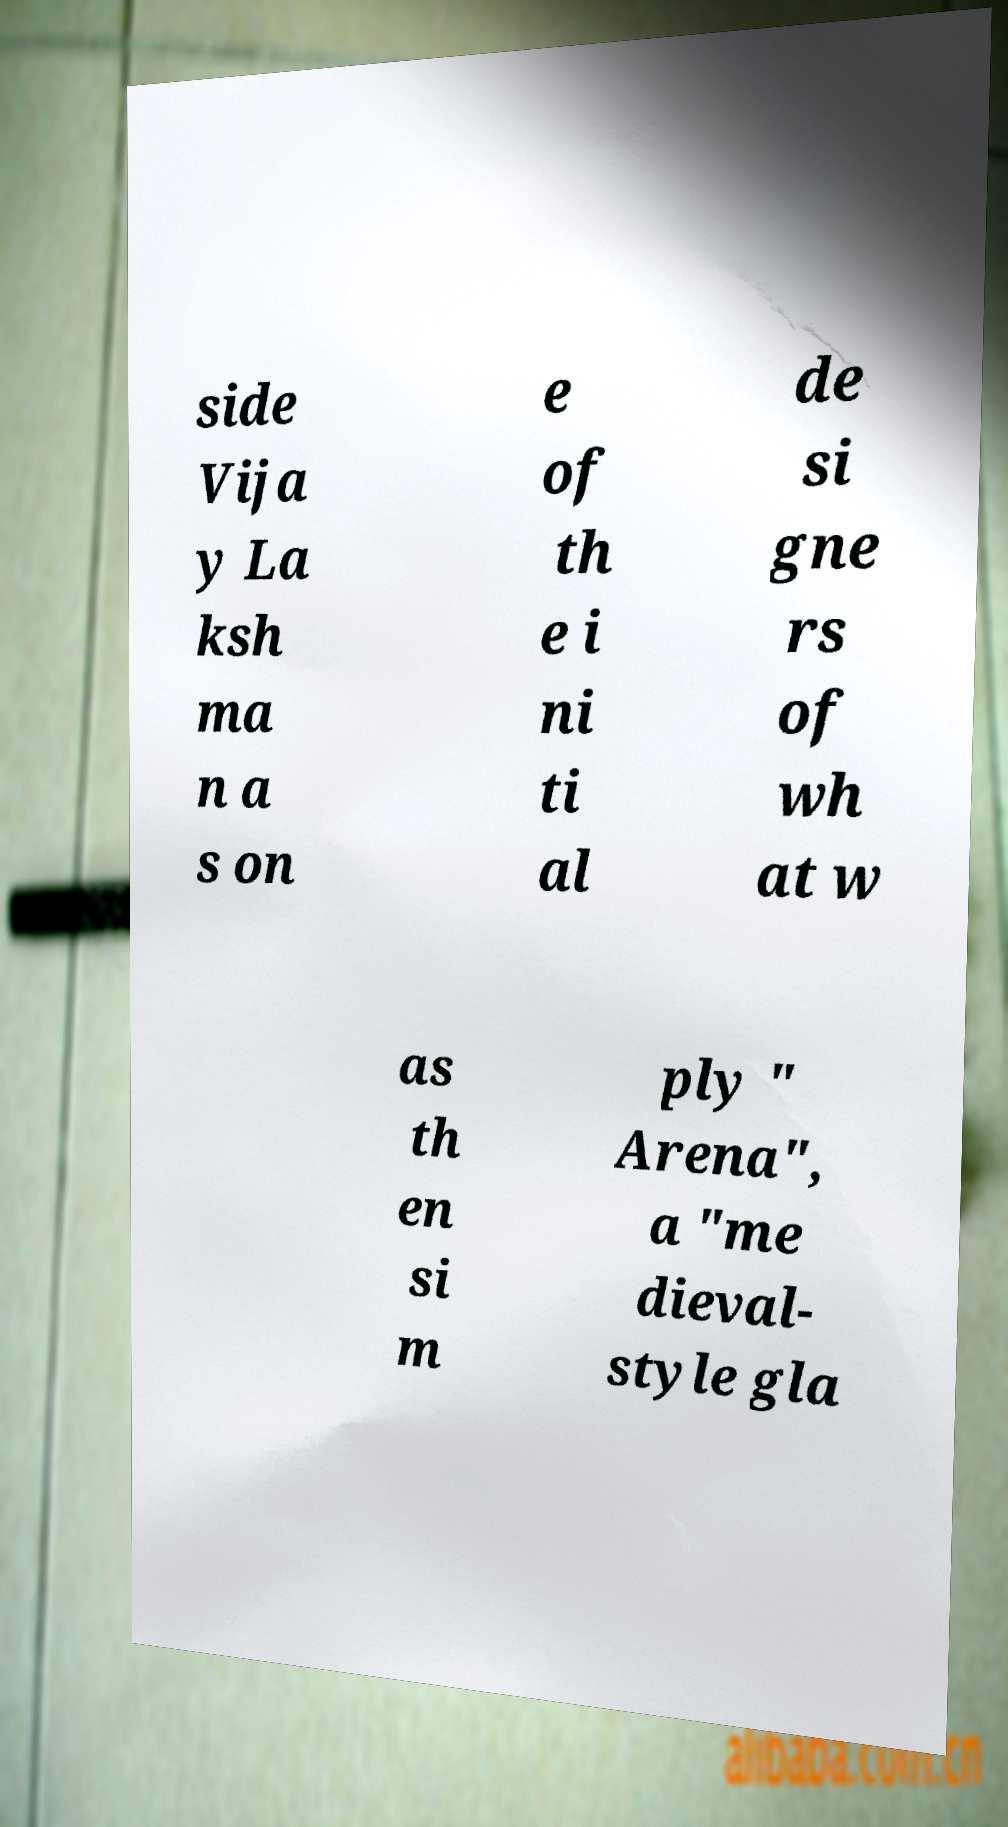For documentation purposes, I need the text within this image transcribed. Could you provide that? side Vija y La ksh ma n a s on e of th e i ni ti al de si gne rs of wh at w as th en si m ply " Arena", a "me dieval- style gla 